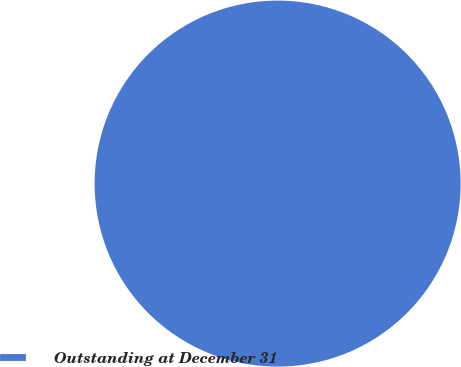Convert chart to OTSL. <chart><loc_0><loc_0><loc_500><loc_500><pie_chart><fcel>Outstanding at December 31<nl><fcel>100.0%<nl></chart> 